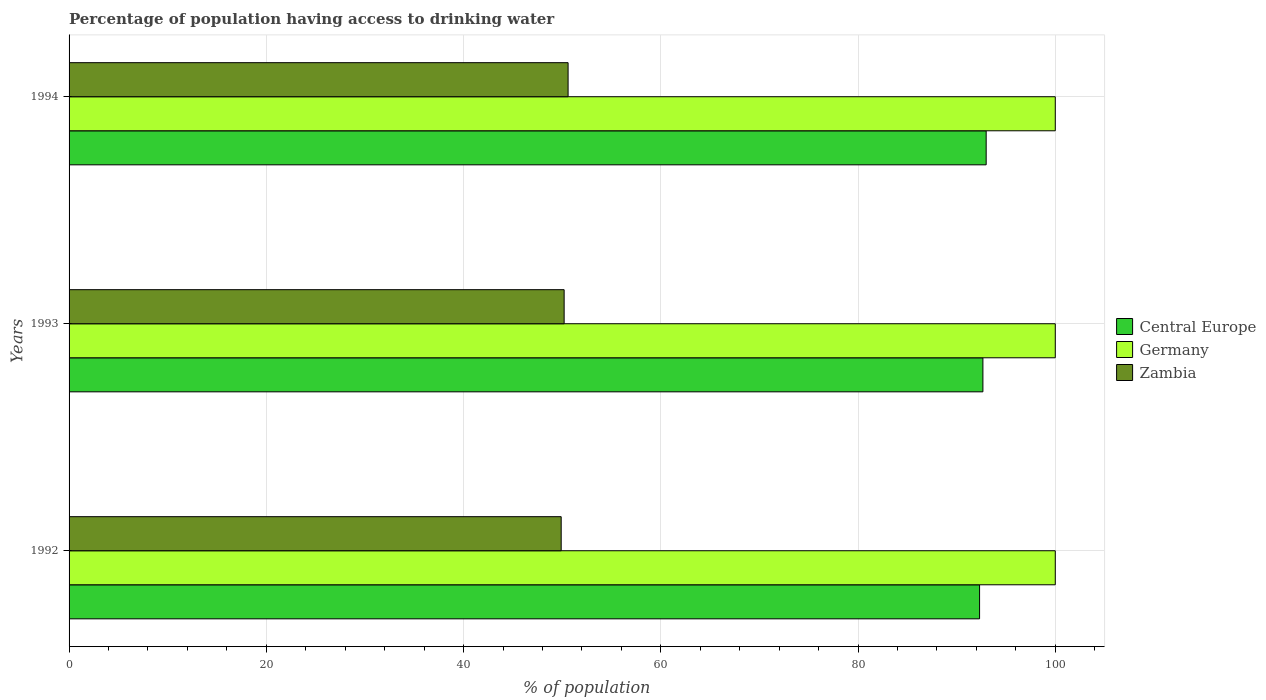How many different coloured bars are there?
Offer a very short reply. 3. How many groups of bars are there?
Your answer should be very brief. 3. Are the number of bars per tick equal to the number of legend labels?
Offer a terse response. Yes. Are the number of bars on each tick of the Y-axis equal?
Make the answer very short. Yes. How many bars are there on the 3rd tick from the top?
Give a very brief answer. 3. What is the label of the 3rd group of bars from the top?
Give a very brief answer. 1992. In how many cases, is the number of bars for a given year not equal to the number of legend labels?
Your answer should be compact. 0. What is the percentage of population having access to drinking water in Zambia in 1992?
Make the answer very short. 49.9. Across all years, what is the maximum percentage of population having access to drinking water in Central Europe?
Your response must be concise. 92.99. Across all years, what is the minimum percentage of population having access to drinking water in Central Europe?
Offer a terse response. 92.32. What is the total percentage of population having access to drinking water in Central Europe in the graph?
Keep it short and to the point. 277.98. What is the difference between the percentage of population having access to drinking water in Zambia in 1992 and that in 1993?
Offer a very short reply. -0.3. What is the difference between the percentage of population having access to drinking water in Central Europe in 1992 and the percentage of population having access to drinking water in Germany in 1993?
Your answer should be very brief. -7.68. What is the average percentage of population having access to drinking water in Central Europe per year?
Keep it short and to the point. 92.66. In the year 1992, what is the difference between the percentage of population having access to drinking water in Central Europe and percentage of population having access to drinking water in Germany?
Provide a short and direct response. -7.68. What is the difference between the highest and the lowest percentage of population having access to drinking water in Central Europe?
Offer a very short reply. 0.67. In how many years, is the percentage of population having access to drinking water in Zambia greater than the average percentage of population having access to drinking water in Zambia taken over all years?
Your answer should be very brief. 1. What does the 3rd bar from the top in 1992 represents?
Keep it short and to the point. Central Europe. What does the 2nd bar from the bottom in 1993 represents?
Keep it short and to the point. Germany. Is it the case that in every year, the sum of the percentage of population having access to drinking water in Germany and percentage of population having access to drinking water in Zambia is greater than the percentage of population having access to drinking water in Central Europe?
Provide a succinct answer. Yes. How many bars are there?
Offer a very short reply. 9. What is the difference between two consecutive major ticks on the X-axis?
Offer a terse response. 20. Does the graph contain grids?
Your response must be concise. Yes. What is the title of the graph?
Give a very brief answer. Percentage of population having access to drinking water. Does "Moldova" appear as one of the legend labels in the graph?
Provide a succinct answer. No. What is the label or title of the X-axis?
Provide a short and direct response. % of population. What is the label or title of the Y-axis?
Your response must be concise. Years. What is the % of population in Central Europe in 1992?
Your response must be concise. 92.32. What is the % of population of Zambia in 1992?
Your answer should be very brief. 49.9. What is the % of population in Central Europe in 1993?
Ensure brevity in your answer.  92.66. What is the % of population of Germany in 1993?
Offer a very short reply. 100. What is the % of population of Zambia in 1993?
Your answer should be very brief. 50.2. What is the % of population of Central Europe in 1994?
Keep it short and to the point. 92.99. What is the % of population in Zambia in 1994?
Your answer should be very brief. 50.6. Across all years, what is the maximum % of population in Central Europe?
Ensure brevity in your answer.  92.99. Across all years, what is the maximum % of population of Germany?
Ensure brevity in your answer.  100. Across all years, what is the maximum % of population in Zambia?
Ensure brevity in your answer.  50.6. Across all years, what is the minimum % of population in Central Europe?
Offer a terse response. 92.32. Across all years, what is the minimum % of population of Germany?
Your response must be concise. 100. Across all years, what is the minimum % of population of Zambia?
Offer a very short reply. 49.9. What is the total % of population of Central Europe in the graph?
Offer a terse response. 277.98. What is the total % of population in Germany in the graph?
Ensure brevity in your answer.  300. What is the total % of population in Zambia in the graph?
Your answer should be compact. 150.7. What is the difference between the % of population in Central Europe in 1992 and that in 1993?
Your answer should be compact. -0.34. What is the difference between the % of population of Zambia in 1992 and that in 1993?
Your answer should be compact. -0.3. What is the difference between the % of population of Central Europe in 1992 and that in 1994?
Keep it short and to the point. -0.67. What is the difference between the % of population of Germany in 1992 and that in 1994?
Ensure brevity in your answer.  0. What is the difference between the % of population in Zambia in 1992 and that in 1994?
Offer a terse response. -0.7. What is the difference between the % of population of Central Europe in 1993 and that in 1994?
Your answer should be very brief. -0.33. What is the difference between the % of population of Central Europe in 1992 and the % of population of Germany in 1993?
Make the answer very short. -7.68. What is the difference between the % of population in Central Europe in 1992 and the % of population in Zambia in 1993?
Provide a short and direct response. 42.12. What is the difference between the % of population of Germany in 1992 and the % of population of Zambia in 1993?
Ensure brevity in your answer.  49.8. What is the difference between the % of population of Central Europe in 1992 and the % of population of Germany in 1994?
Keep it short and to the point. -7.68. What is the difference between the % of population of Central Europe in 1992 and the % of population of Zambia in 1994?
Offer a terse response. 41.72. What is the difference between the % of population of Germany in 1992 and the % of population of Zambia in 1994?
Your response must be concise. 49.4. What is the difference between the % of population of Central Europe in 1993 and the % of population of Germany in 1994?
Keep it short and to the point. -7.34. What is the difference between the % of population in Central Europe in 1993 and the % of population in Zambia in 1994?
Keep it short and to the point. 42.06. What is the difference between the % of population in Germany in 1993 and the % of population in Zambia in 1994?
Offer a very short reply. 49.4. What is the average % of population of Central Europe per year?
Offer a very short reply. 92.66. What is the average % of population in Zambia per year?
Your answer should be compact. 50.23. In the year 1992, what is the difference between the % of population in Central Europe and % of population in Germany?
Offer a terse response. -7.68. In the year 1992, what is the difference between the % of population in Central Europe and % of population in Zambia?
Provide a short and direct response. 42.42. In the year 1992, what is the difference between the % of population of Germany and % of population of Zambia?
Offer a very short reply. 50.1. In the year 1993, what is the difference between the % of population in Central Europe and % of population in Germany?
Provide a short and direct response. -7.34. In the year 1993, what is the difference between the % of population of Central Europe and % of population of Zambia?
Provide a succinct answer. 42.46. In the year 1993, what is the difference between the % of population in Germany and % of population in Zambia?
Give a very brief answer. 49.8. In the year 1994, what is the difference between the % of population in Central Europe and % of population in Germany?
Your answer should be very brief. -7.01. In the year 1994, what is the difference between the % of population in Central Europe and % of population in Zambia?
Your answer should be compact. 42.39. In the year 1994, what is the difference between the % of population of Germany and % of population of Zambia?
Your response must be concise. 49.4. What is the ratio of the % of population of Central Europe in 1992 to that in 1993?
Ensure brevity in your answer.  1. What is the ratio of the % of population in Germany in 1992 to that in 1993?
Your answer should be compact. 1. What is the ratio of the % of population of Zambia in 1992 to that in 1993?
Offer a very short reply. 0.99. What is the ratio of the % of population of Central Europe in 1992 to that in 1994?
Offer a very short reply. 0.99. What is the ratio of the % of population in Zambia in 1992 to that in 1994?
Keep it short and to the point. 0.99. What is the ratio of the % of population of Germany in 1993 to that in 1994?
Offer a terse response. 1. What is the ratio of the % of population of Zambia in 1993 to that in 1994?
Provide a short and direct response. 0.99. What is the difference between the highest and the second highest % of population in Central Europe?
Offer a terse response. 0.33. What is the difference between the highest and the second highest % of population in Germany?
Keep it short and to the point. 0. What is the difference between the highest and the second highest % of population of Zambia?
Give a very brief answer. 0.4. What is the difference between the highest and the lowest % of population of Central Europe?
Offer a terse response. 0.67. What is the difference between the highest and the lowest % of population in Zambia?
Offer a terse response. 0.7. 